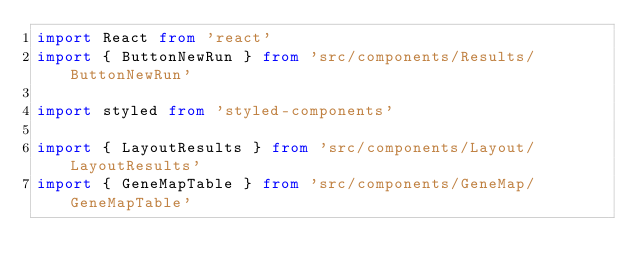Convert code to text. <code><loc_0><loc_0><loc_500><loc_500><_TypeScript_>import React from 'react'
import { ButtonNewRun } from 'src/components/Results/ButtonNewRun'

import styled from 'styled-components'

import { LayoutResults } from 'src/components/Layout/LayoutResults'
import { GeneMapTable } from 'src/components/GeneMap/GeneMapTable'</code> 